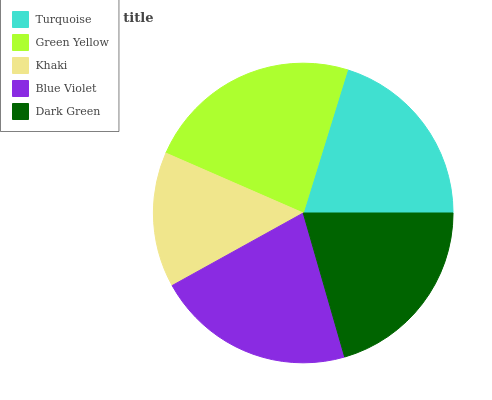Is Khaki the minimum?
Answer yes or no. Yes. Is Green Yellow the maximum?
Answer yes or no. Yes. Is Green Yellow the minimum?
Answer yes or no. No. Is Khaki the maximum?
Answer yes or no. No. Is Green Yellow greater than Khaki?
Answer yes or no. Yes. Is Khaki less than Green Yellow?
Answer yes or no. Yes. Is Khaki greater than Green Yellow?
Answer yes or no. No. Is Green Yellow less than Khaki?
Answer yes or no. No. Is Dark Green the high median?
Answer yes or no. Yes. Is Dark Green the low median?
Answer yes or no. Yes. Is Green Yellow the high median?
Answer yes or no. No. Is Khaki the low median?
Answer yes or no. No. 